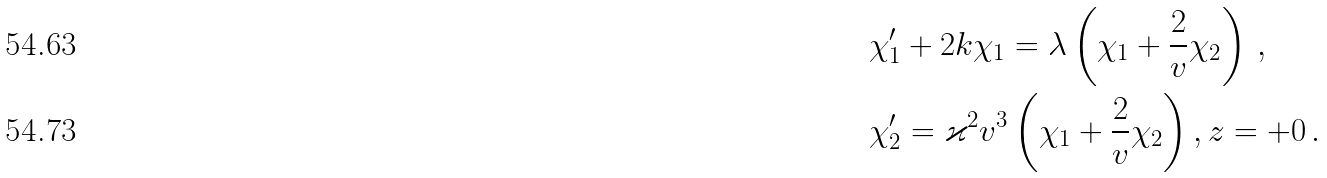<formula> <loc_0><loc_0><loc_500><loc_500>& \chi _ { 1 } ^ { \prime } + 2 k \chi _ { 1 } = \lambda \left ( \chi _ { 1 } + \frac { 2 } { v } \chi _ { 2 } \right ) \, , \\ & \chi _ { 2 } ^ { \prime } = \varkappa ^ { 2 } v ^ { 3 } \left ( \chi _ { 1 } + \frac { 2 } { v } \chi _ { 2 } \right ) , z = + 0 \, .</formula> 